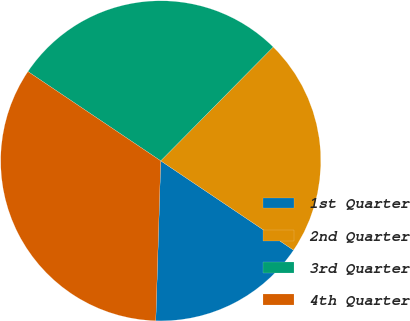Convert chart to OTSL. <chart><loc_0><loc_0><loc_500><loc_500><pie_chart><fcel>1st Quarter<fcel>2nd Quarter<fcel>3rd Quarter<fcel>4th Quarter<nl><fcel>16.07%<fcel>22.02%<fcel>27.98%<fcel>33.93%<nl></chart> 